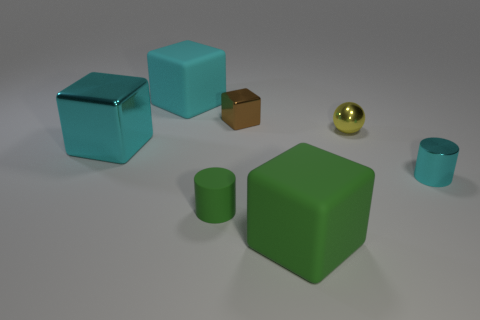There is a large thing that is behind the small yellow thing; what is its shape? cube 